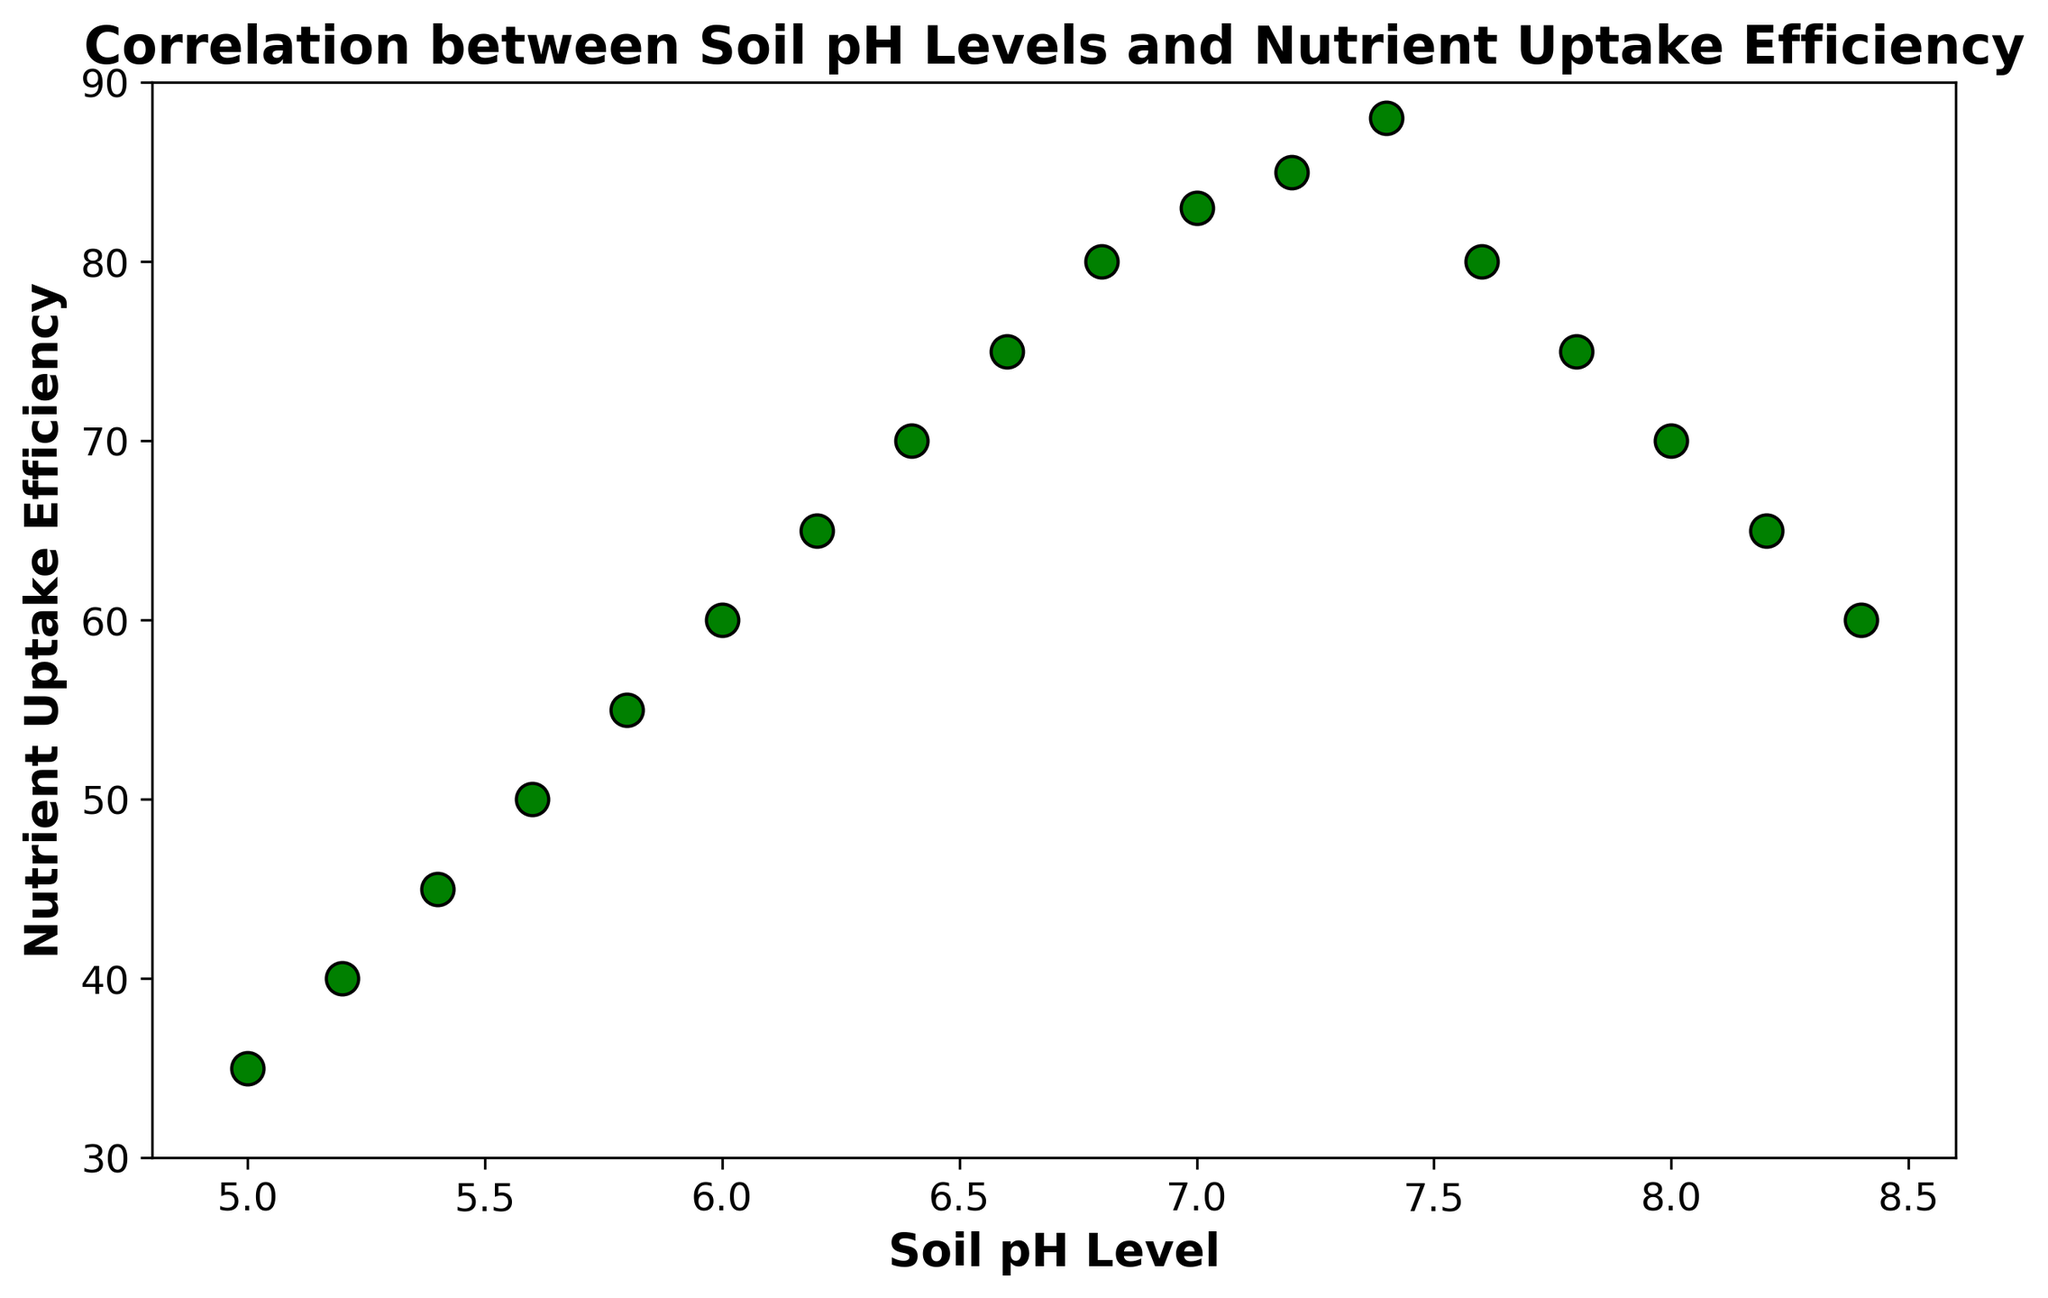What is the general trend of nutrient uptake efficiency with increasing soil pH? By observing the scatter plot, it is evident that nutrient uptake efficiency increases as soil pH increases from 5.0 to approximately 7.4. After 7.4, nutrient uptake efficiency decreases as soil pH continues to rise.
Answer: Increases until 7.4, then decreases What is the nutrient uptake efficiency at a soil pH level of 6.4? By locating the point on the scatter plot where soil pH is 6.4, you can see that the corresponding nutrient uptake efficiency is 70.
Answer: 70 At which soil pH level does the nutrient uptake efficiency reach its peak? The peak in the scatter plot is at nutrient uptake efficiency of 88. Tracing this peak horizontally to the soil pH axis shows the peak occurs at 7.4.
Answer: 7.4 How does the nutrient uptake efficiency at pH 8.0 compare to that at pH 6.8? From the scatter plot, the nutrient uptake efficiency at pH 8.0 is 70, while at pH 6.8 it is 80. Therefore, nutrient uptake efficiency is higher at pH 6.8.
Answer: Higher at pH 6.8 What is the average nutrient uptake efficiency for soil pH levels between 6.0 and 7.0? Identify the nutrient uptake efficiency values for pH levels 6.0, 6.2, 6.4, 6.6, 6.8, and 7.0 from the scatter plot: (60, 65, 70, 75, 80, 83). Calculate the average: (60 + 65 + 70 + 75 + 80 + 83) / 6 = 72.17.
Answer: 72.17 What is the difference in nutrient uptake efficiency between soil pH levels 7.2 and 7.8? From the scatter plot, the nutrient uptake efficiency at pH 7.2 is 85, and at pH 7.8 it is 75. The difference is 85 - 75 = 10.
Answer: 10 How does the nutrient uptake efficiency at soil pH of 8.4 compare visually to that at soil pH 6.0? By comparing the two points on the scatter plot for pH 8.4 and 6.0, you see that the nutrient uptake efficiency at 8.4 (60) is lower than at 6.0 (60).
Answer: Lower at 8.4 What is the general shape of the scatter plot in terms of nutrient uptake efficiency across the soil pH spectrum? The scatter plot shows an increasing trend in nutrient uptake efficiency from soil pH 5.0 to 7.4, followed by a decreasing trend from 7.4 to 8.4, forming an inverted U-shaped pattern.
Answer: Inverted U-shaped What soil pH levels have a nutrient uptake efficiency greater than 80? From the scatter plot, nutrient uptake efficiencies greater than 80 occur at soil pH levels of 6.8, 7.0, 7.2, and 7.4.
Answer: 6.8, 7.0, 7.2, 7.4 